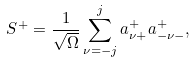<formula> <loc_0><loc_0><loc_500><loc_500>S ^ { + } = \frac { 1 } { \sqrt { \Omega } } \sum _ { \nu = - j } ^ { j } a _ { \nu + } ^ { + } a _ { - \nu - } ^ { + } ,</formula> 